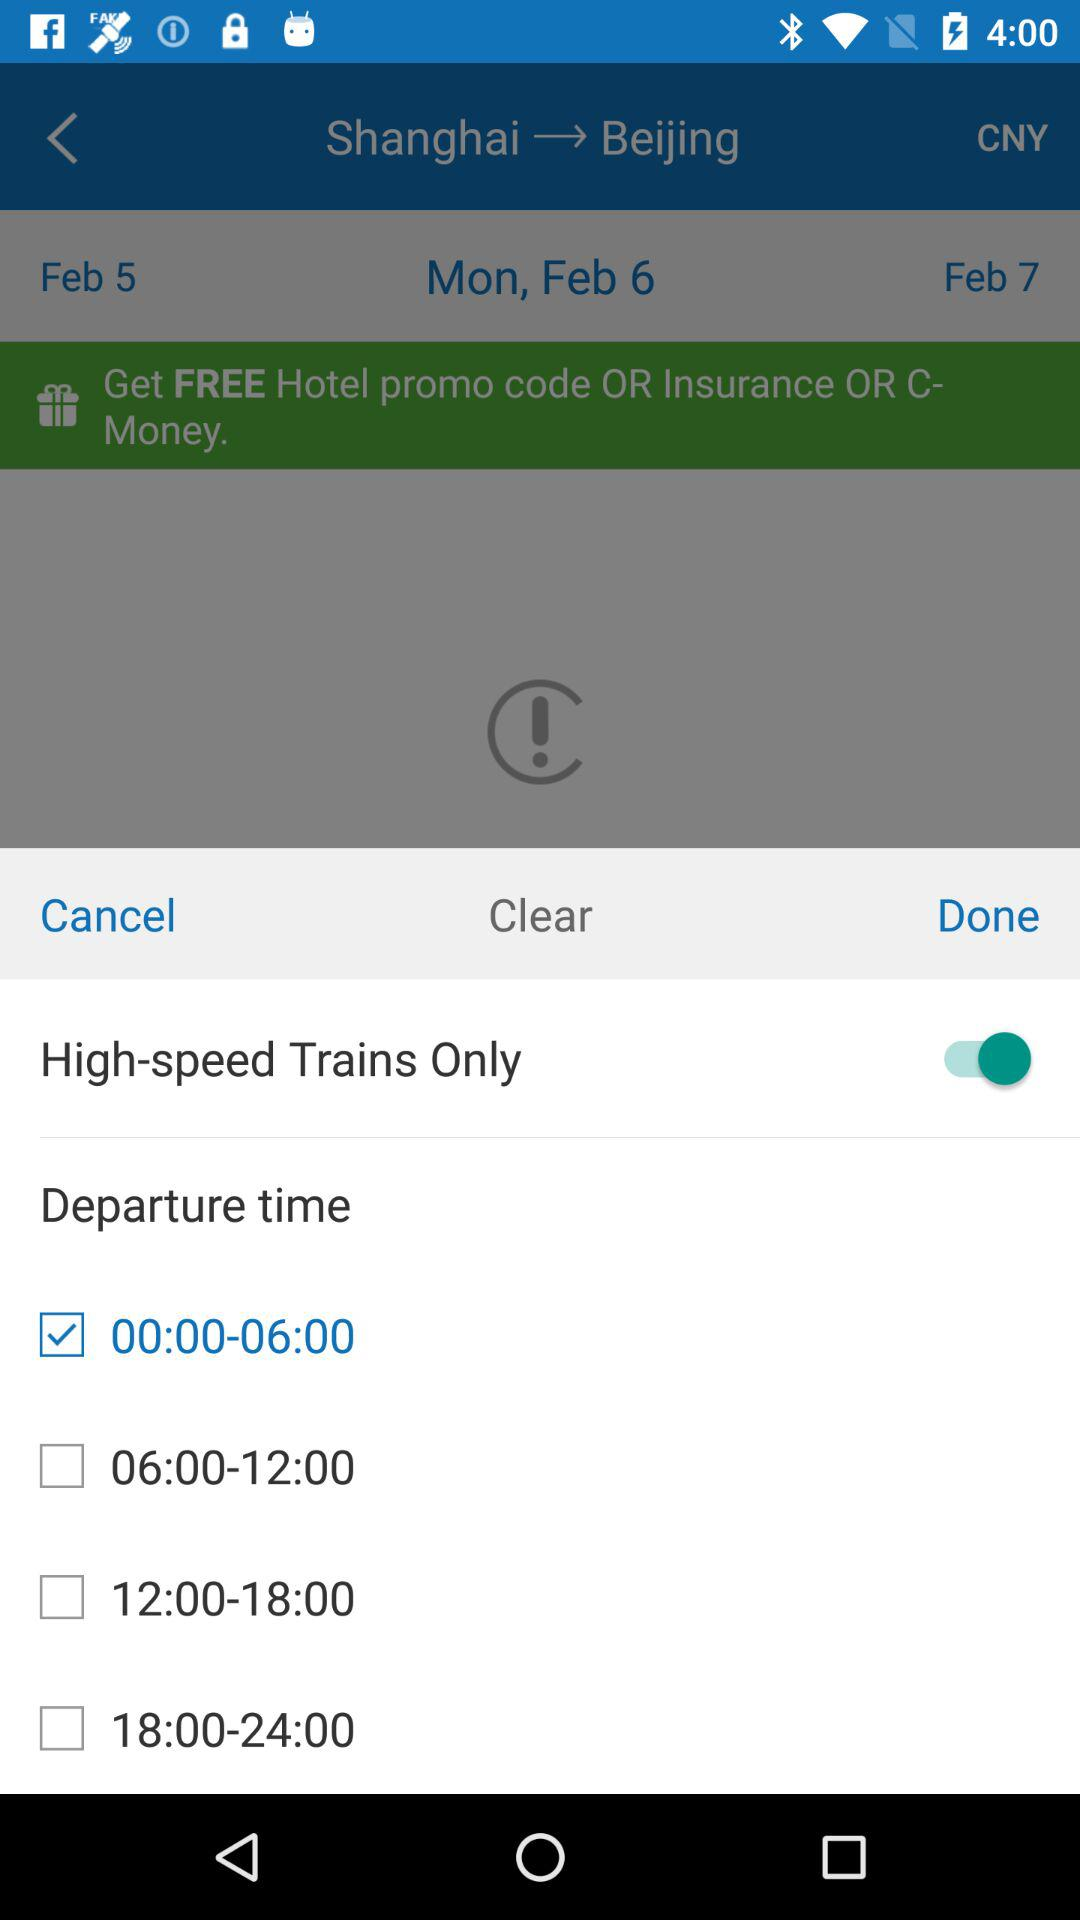What is the selected departure time? The selected departure time is "00:00-06:00". 